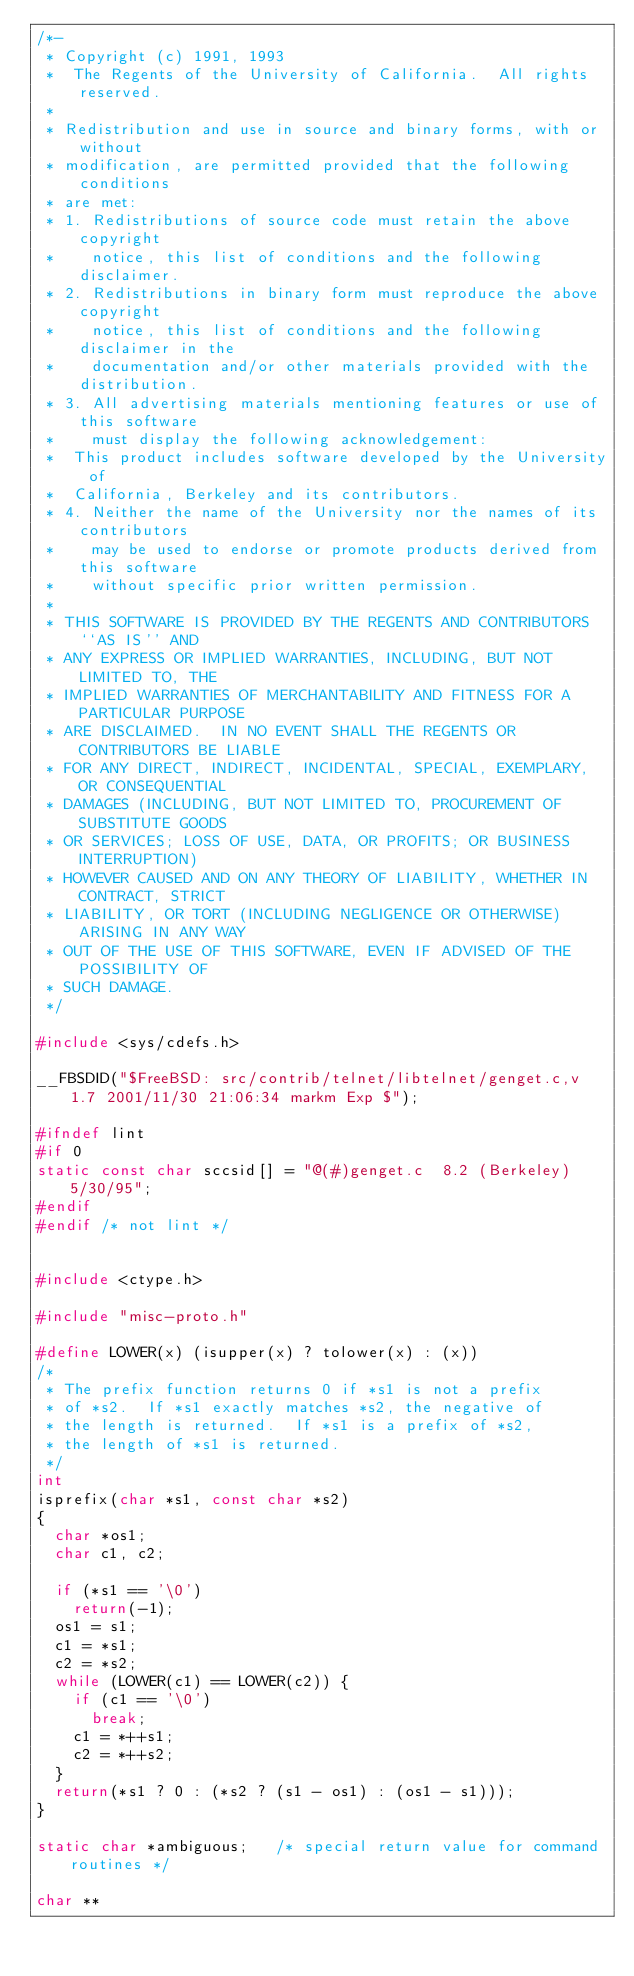Convert code to text. <code><loc_0><loc_0><loc_500><loc_500><_C_>/*-
 * Copyright (c) 1991, 1993
 *	The Regents of the University of California.  All rights reserved.
 *
 * Redistribution and use in source and binary forms, with or without
 * modification, are permitted provided that the following conditions
 * are met:
 * 1. Redistributions of source code must retain the above copyright
 *    notice, this list of conditions and the following disclaimer.
 * 2. Redistributions in binary form must reproduce the above copyright
 *    notice, this list of conditions and the following disclaimer in the
 *    documentation and/or other materials provided with the distribution.
 * 3. All advertising materials mentioning features or use of this software
 *    must display the following acknowledgement:
 *	This product includes software developed by the University of
 *	California, Berkeley and its contributors.
 * 4. Neither the name of the University nor the names of its contributors
 *    may be used to endorse or promote products derived from this software
 *    without specific prior written permission.
 *
 * THIS SOFTWARE IS PROVIDED BY THE REGENTS AND CONTRIBUTORS ``AS IS'' AND
 * ANY EXPRESS OR IMPLIED WARRANTIES, INCLUDING, BUT NOT LIMITED TO, THE
 * IMPLIED WARRANTIES OF MERCHANTABILITY AND FITNESS FOR A PARTICULAR PURPOSE
 * ARE DISCLAIMED.  IN NO EVENT SHALL THE REGENTS OR CONTRIBUTORS BE LIABLE
 * FOR ANY DIRECT, INDIRECT, INCIDENTAL, SPECIAL, EXEMPLARY, OR CONSEQUENTIAL
 * DAMAGES (INCLUDING, BUT NOT LIMITED TO, PROCUREMENT OF SUBSTITUTE GOODS
 * OR SERVICES; LOSS OF USE, DATA, OR PROFITS; OR BUSINESS INTERRUPTION)
 * HOWEVER CAUSED AND ON ANY THEORY OF LIABILITY, WHETHER IN CONTRACT, STRICT
 * LIABILITY, OR TORT (INCLUDING NEGLIGENCE OR OTHERWISE) ARISING IN ANY WAY
 * OUT OF THE USE OF THIS SOFTWARE, EVEN IF ADVISED OF THE POSSIBILITY OF
 * SUCH DAMAGE.
 */

#include <sys/cdefs.h>

__FBSDID("$FreeBSD: src/contrib/telnet/libtelnet/genget.c,v 1.7 2001/11/30 21:06:34 markm Exp $");

#ifndef lint
#if 0
static const char sccsid[] = "@(#)genget.c	8.2 (Berkeley) 5/30/95";
#endif
#endif /* not lint */


#include <ctype.h>

#include "misc-proto.h"

#define	LOWER(x) (isupper(x) ? tolower(x) : (x))
/*
 * The prefix function returns 0 if *s1 is not a prefix
 * of *s2.  If *s1 exactly matches *s2, the negative of
 * the length is returned.  If *s1 is a prefix of *s2,
 * the length of *s1 is returned.
 */
int
isprefix(char *s1, const char *s2)
{
	char *os1;
	char c1, c2;

	if (*s1 == '\0')
		return(-1);
	os1 = s1;
	c1 = *s1;
	c2 = *s2;
	while (LOWER(c1) == LOWER(c2)) {
		if (c1 == '\0')
			break;
		c1 = *++s1;
		c2 = *++s2;
	}
	return(*s1 ? 0 : (*s2 ? (s1 - os1) : (os1 - s1)));
}

static char *ambiguous;		/* special return value for command routines */

char **</code> 